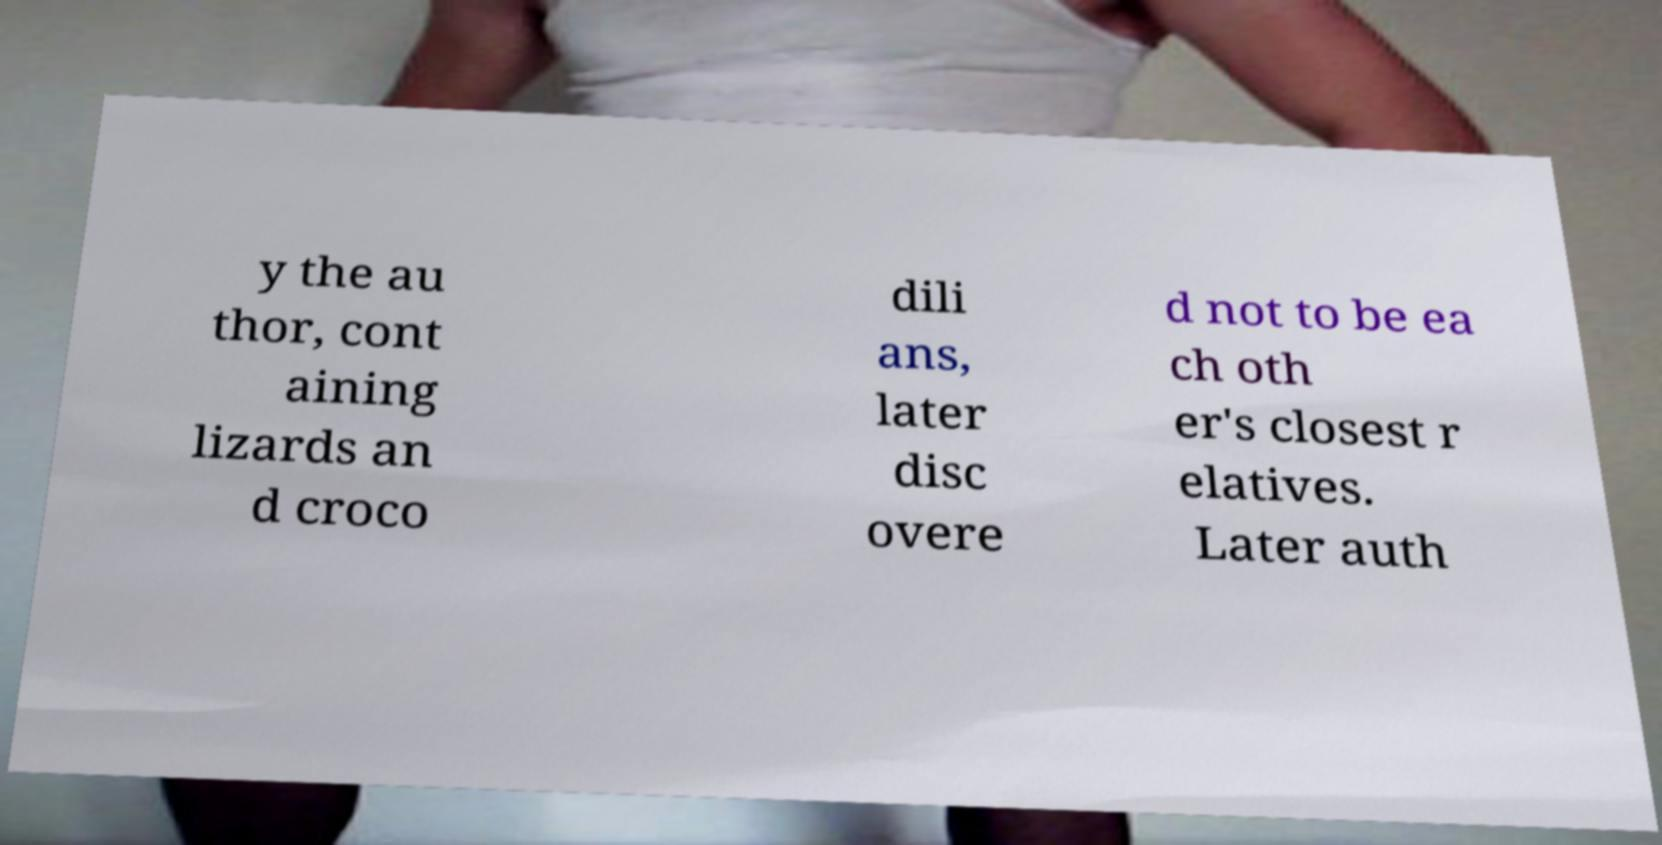Can you read and provide the text displayed in the image?This photo seems to have some interesting text. Can you extract and type it out for me? y the au thor, cont aining lizards an d croco dili ans, later disc overe d not to be ea ch oth er's closest r elatives. Later auth 